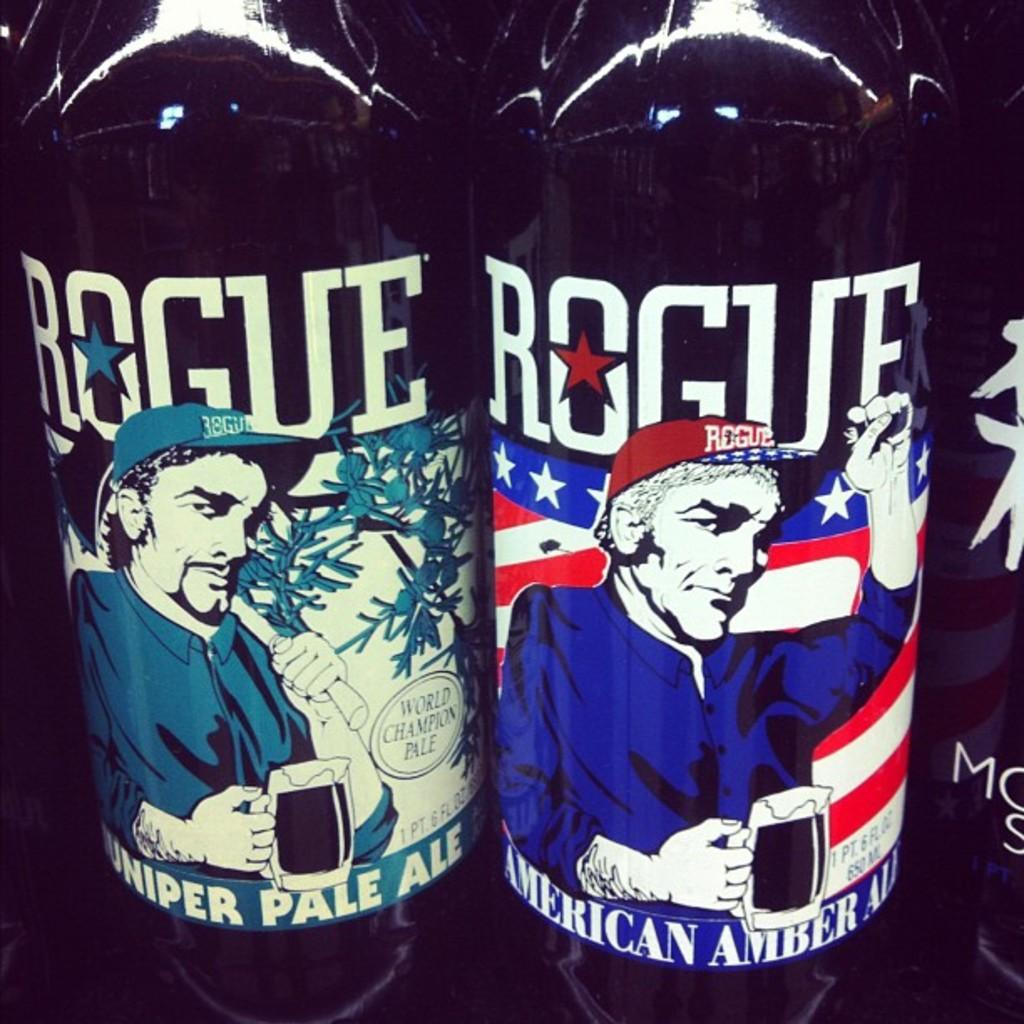<image>
Relay a brief, clear account of the picture shown. Two bottles of Rogue ales sit next to each other, one with a more colorful label 